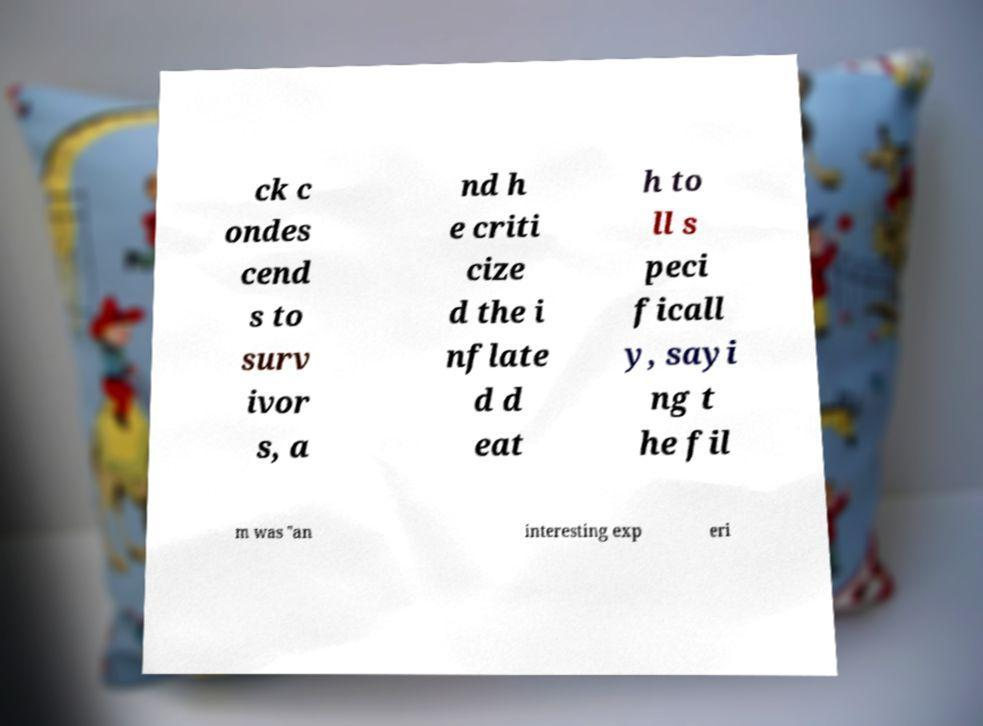Could you assist in decoding the text presented in this image and type it out clearly? ck c ondes cend s to surv ivor s, a nd h e criti cize d the i nflate d d eat h to ll s peci ficall y, sayi ng t he fil m was "an interesting exp eri 